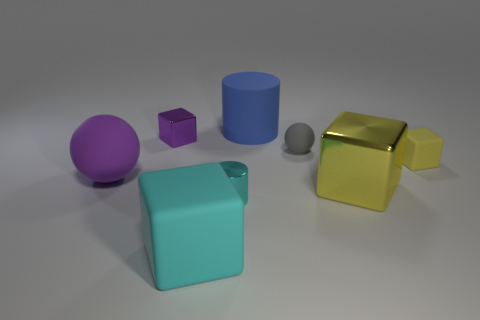Subtract 1 blocks. How many blocks are left? 3 Add 2 large cyan blocks. How many objects exist? 10 Subtract all cylinders. How many objects are left? 6 Add 4 small green metal blocks. How many small green metal blocks exist? 4 Subtract 1 gray balls. How many objects are left? 7 Subtract all small blue balls. Subtract all big cyan things. How many objects are left? 7 Add 7 big blue things. How many big blue things are left? 8 